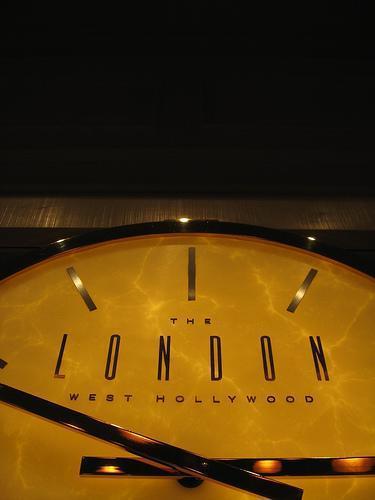How many words are on the clock?
Give a very brief answer. 4. 